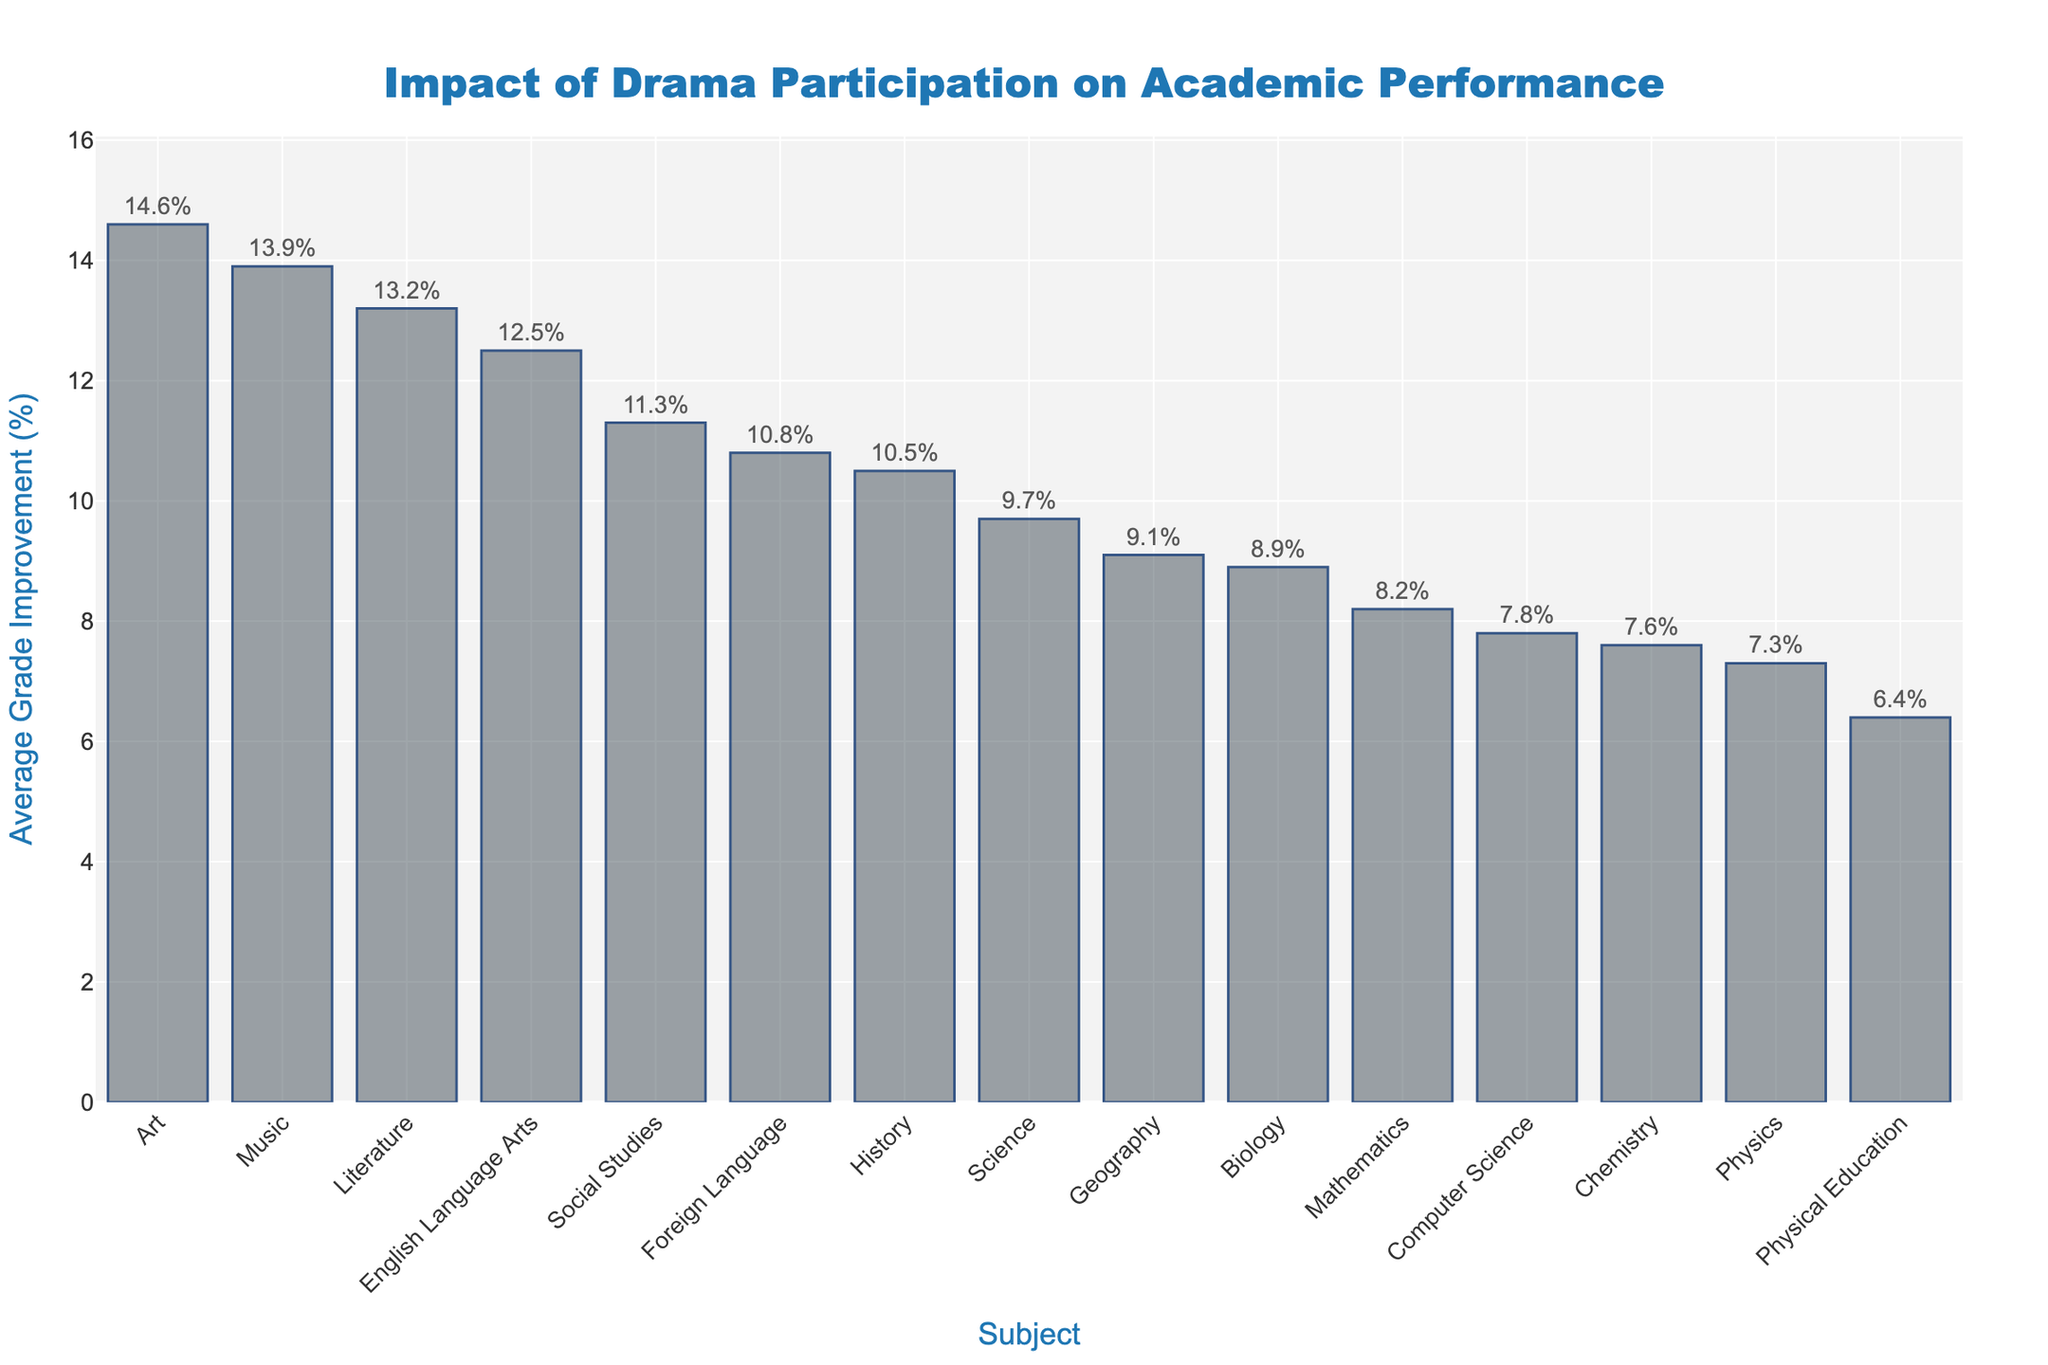Which subject shows the highest average grade improvement? To find this, look at the bar heights and their corresponding labels. The tallest bar represents the subject with the highest grade improvement.
Answer: Art Which subject shows the lowest average grade improvement? Identify the shortest bar and check its label to determine which subject it represents.
Answer: Physical Education How much higher is the average grade improvement in Music compared to Mathematics? Locate the bars for Music and Mathematics. Subtract the height of the Mathematics bar from the height of the Music bar to find the difference.
Answer: 5.7% What is the sum of the average grade improvements for Science, Social Studies, and History? Find the values for these subjects, then add them together: 9.7% (Science) + 11.3% (Social Studies) + 10.5% (History).
Answer: 31.5% Which subjects have an average grade improvement above 10%? Identify all bars above the 10% mark and note their labels.
Answer: English Language Arts, Social Studies, Foreign Language, Art, Music, Literature, History Are there any subjects with an average grade improvement between 7% and 9%? If so, which ones? Check the bars within the 7% to 9% range and identify their labels.
Answer: Computer Science, Physics, Chemistry, Biology What is the average grade improvement for all the subjects listed? Add all the percentages and divide by the number of subjects to find the mean improvement. Sum is 154.9%, so 154.9%/15 = approximately 10.3%.
Answer: Approximately 10.3% Which subject has a higher average grade improvement: Biology or Geography? Compare the bar heights for Biology and Geography to see which is taller.
Answer: Geography What is the range of average grade improvements across all subjects? Subtract the lowest improvement (Physical Education) from the highest improvement (Art). Range = 14.6% - 6.4%.
Answer: 8.2% In which subject category does the displayed improvement belong: less than 7%, 7%-10%, 10%-13%, or more than 13%? Identify the subjects that fall into each specified range based on their bar heights and labels.
Answer: Varied categories exist: (less than 7%: Physical Education), (7%-10%: Mathematics, Computer Science, Geography, Biology, Chemistry, Physics), (10%-13%: English Language Arts, Social Studies, Foreign Language, History), (more than 13%: Art, Music, Literature) 